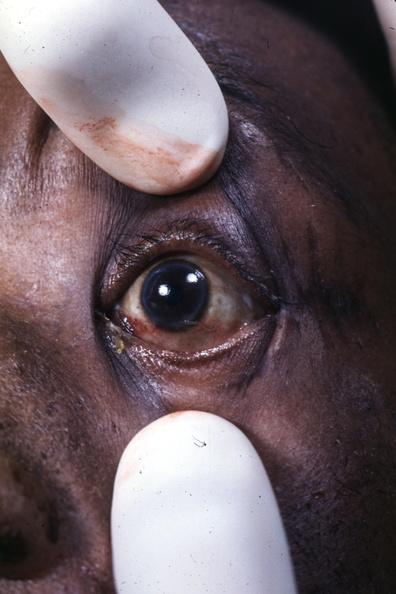s eye present?
Answer the question using a single word or phrase. Yes 